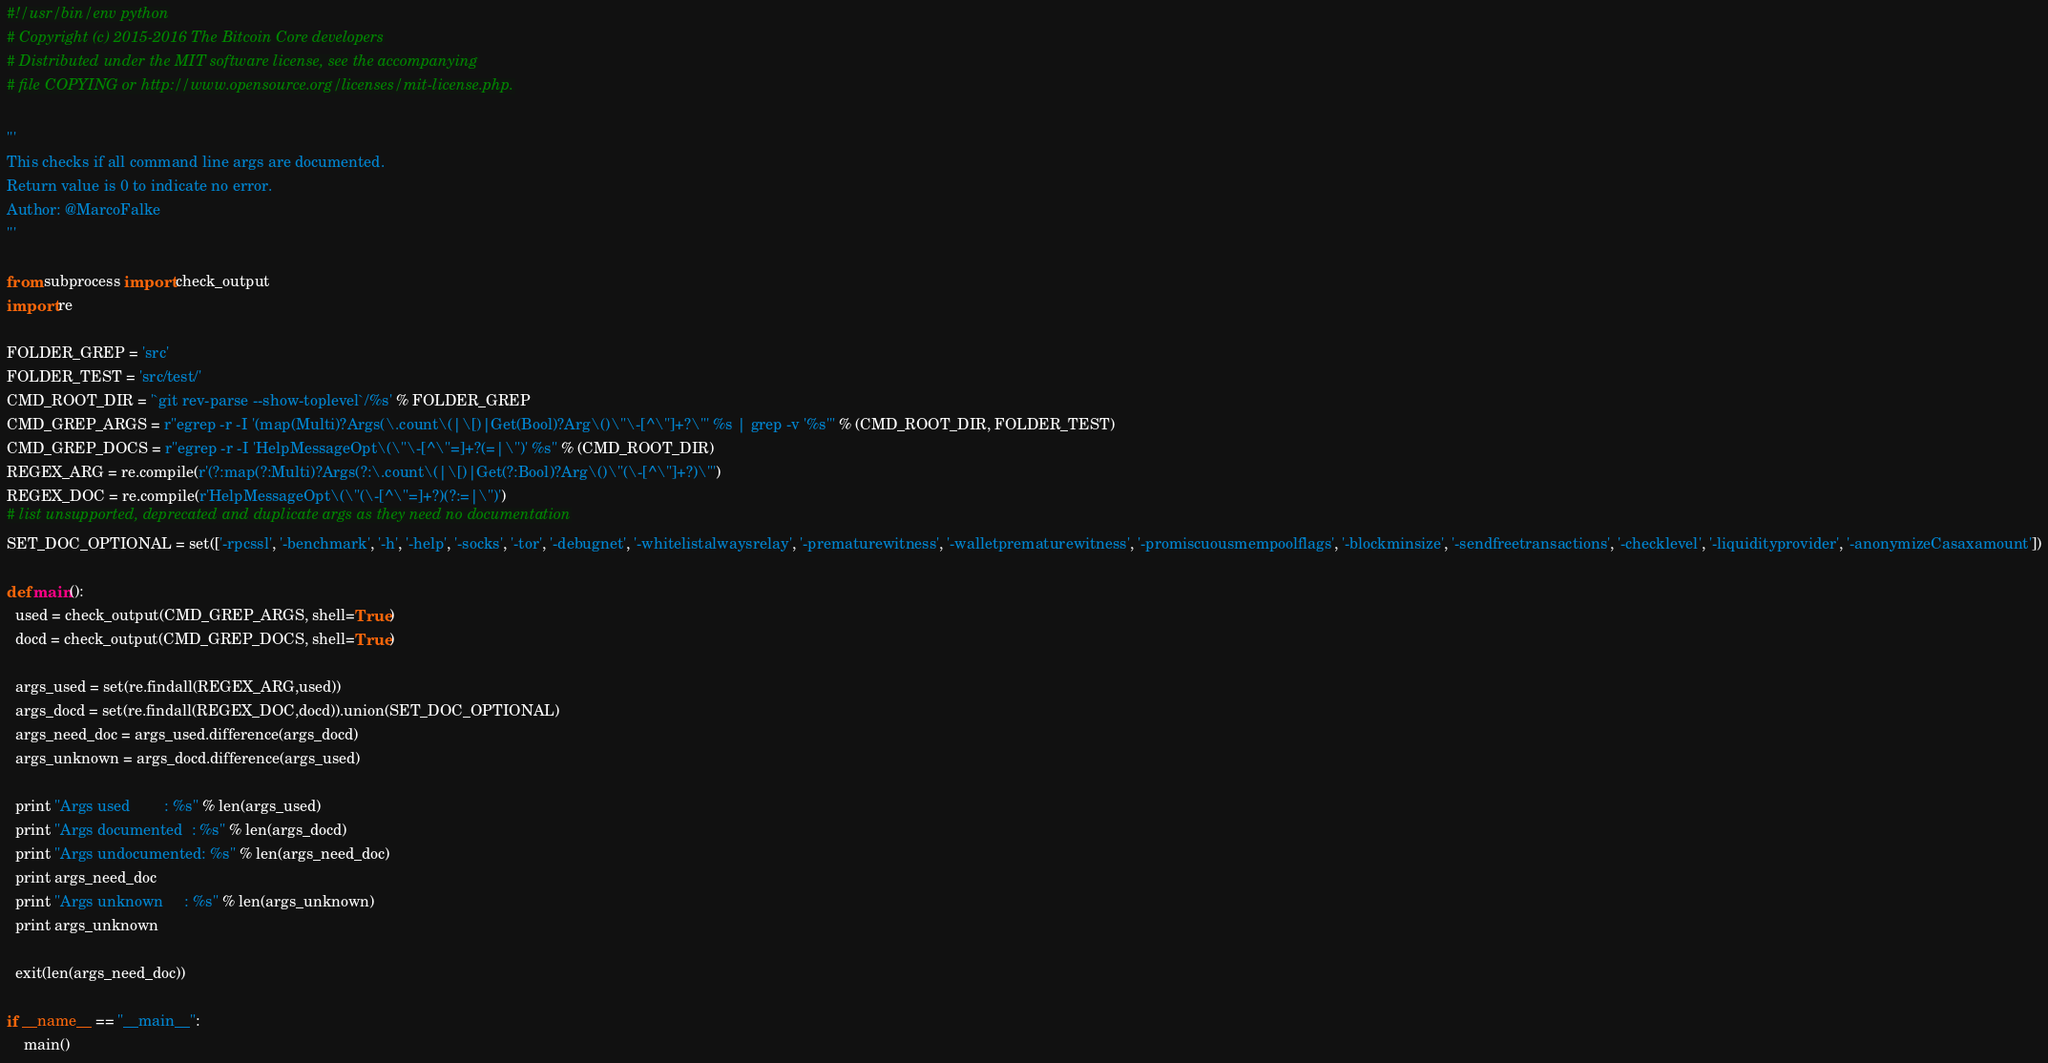<code> <loc_0><loc_0><loc_500><loc_500><_Python_>#!/usr/bin/env python
# Copyright (c) 2015-2016 The Bitcoin Core developers
# Distributed under the MIT software license, see the accompanying
# file COPYING or http://www.opensource.org/licenses/mit-license.php.

'''
This checks if all command line args are documented.
Return value is 0 to indicate no error.
Author: @MarcoFalke
'''

from subprocess import check_output
import re

FOLDER_GREP = 'src'
FOLDER_TEST = 'src/test/'
CMD_ROOT_DIR = '`git rev-parse --show-toplevel`/%s' % FOLDER_GREP
CMD_GREP_ARGS = r"egrep -r -I '(map(Multi)?Args(\.count\(|\[)|Get(Bool)?Arg\()\"\-[^\"]+?\"' %s | grep -v '%s'" % (CMD_ROOT_DIR, FOLDER_TEST)
CMD_GREP_DOCS = r"egrep -r -I 'HelpMessageOpt\(\"\-[^\"=]+?(=|\")' %s" % (CMD_ROOT_DIR)
REGEX_ARG = re.compile(r'(?:map(?:Multi)?Args(?:\.count\(|\[)|Get(?:Bool)?Arg\()\"(\-[^\"]+?)\"')
REGEX_DOC = re.compile(r'HelpMessageOpt\(\"(\-[^\"=]+?)(?:=|\")')
# list unsupported, deprecated and duplicate args as they need no documentation
SET_DOC_OPTIONAL = set(['-rpcssl', '-benchmark', '-h', '-help', '-socks', '-tor', '-debugnet', '-whitelistalwaysrelay', '-prematurewitness', '-walletprematurewitness', '-promiscuousmempoolflags', '-blockminsize', '-sendfreetransactions', '-checklevel', '-liquidityprovider', '-anonymizeCasaxamount'])

def main():
  used = check_output(CMD_GREP_ARGS, shell=True)
  docd = check_output(CMD_GREP_DOCS, shell=True)

  args_used = set(re.findall(REGEX_ARG,used))
  args_docd = set(re.findall(REGEX_DOC,docd)).union(SET_DOC_OPTIONAL)
  args_need_doc = args_used.difference(args_docd)
  args_unknown = args_docd.difference(args_used)

  print "Args used        : %s" % len(args_used)
  print "Args documented  : %s" % len(args_docd)
  print "Args undocumented: %s" % len(args_need_doc)
  print args_need_doc
  print "Args unknown     : %s" % len(args_unknown)
  print args_unknown

  exit(len(args_need_doc))

if __name__ == "__main__":
    main()
</code> 